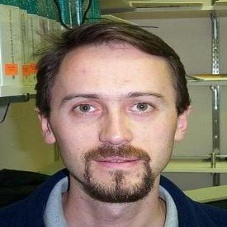How does the lighting affect the perception of the man in the image? The lighting in the image is soft and frontal, illuminating the man's facial features without creating harsh shadows. This kind of lighting tends to flatten features slightly but also emphasizes the texture of the skin and facial hair, contributing to an intimate and detailed view of the subject. It enhances the viewer's ability to perceive subtle details and adds a gentle, accessible quality to his appearance. 